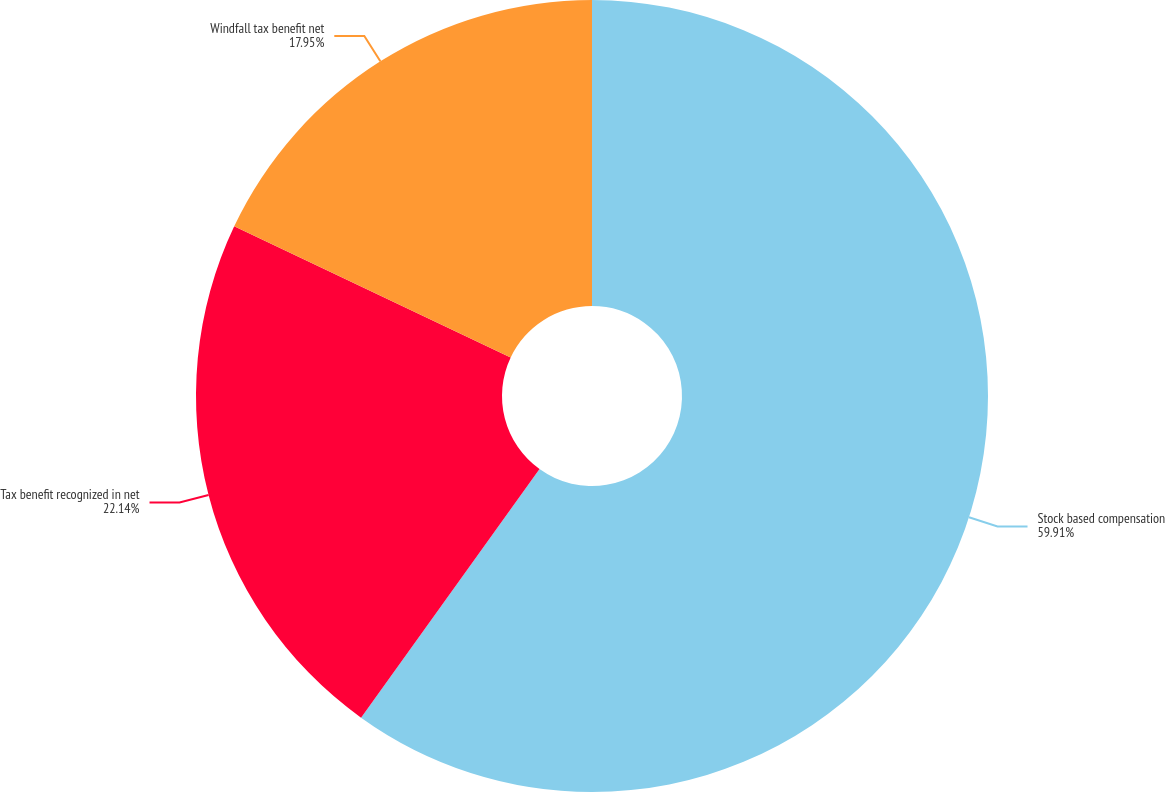Convert chart to OTSL. <chart><loc_0><loc_0><loc_500><loc_500><pie_chart><fcel>Stock based compensation<fcel>Tax benefit recognized in net<fcel>Windfall tax benefit net<nl><fcel>59.91%<fcel>22.14%<fcel>17.95%<nl></chart> 